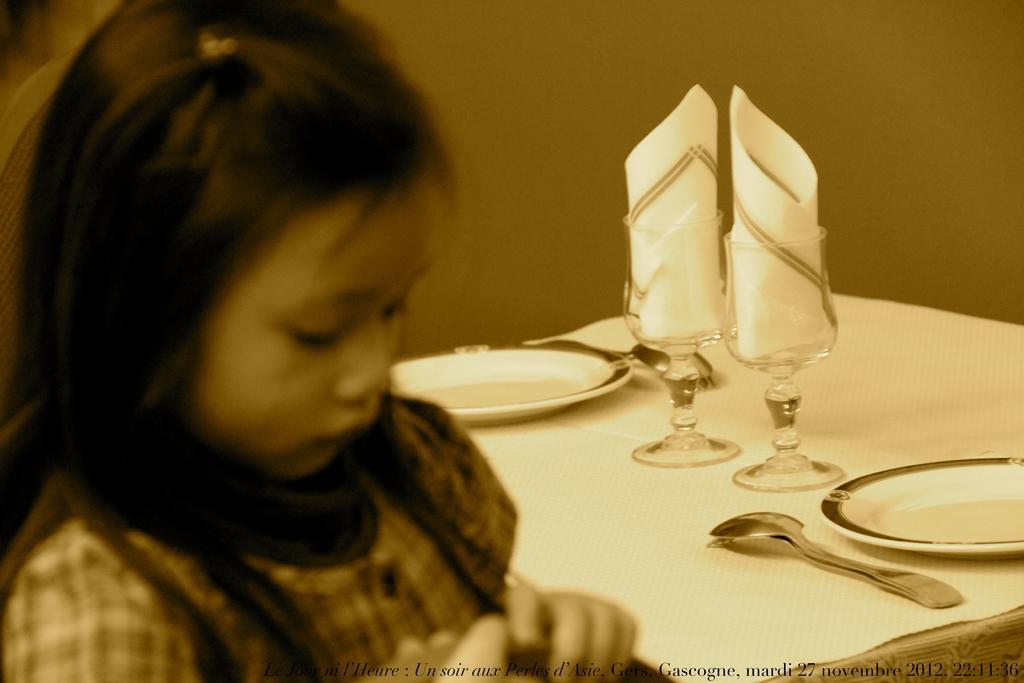Can you describe this image briefly? As we can see in the image there is a women sitting on chair and there is a table over here. On table there are glasses, plates and spoon. 